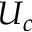Convert formula to latex. <formula><loc_0><loc_0><loc_500><loc_500>U _ { c }</formula> 